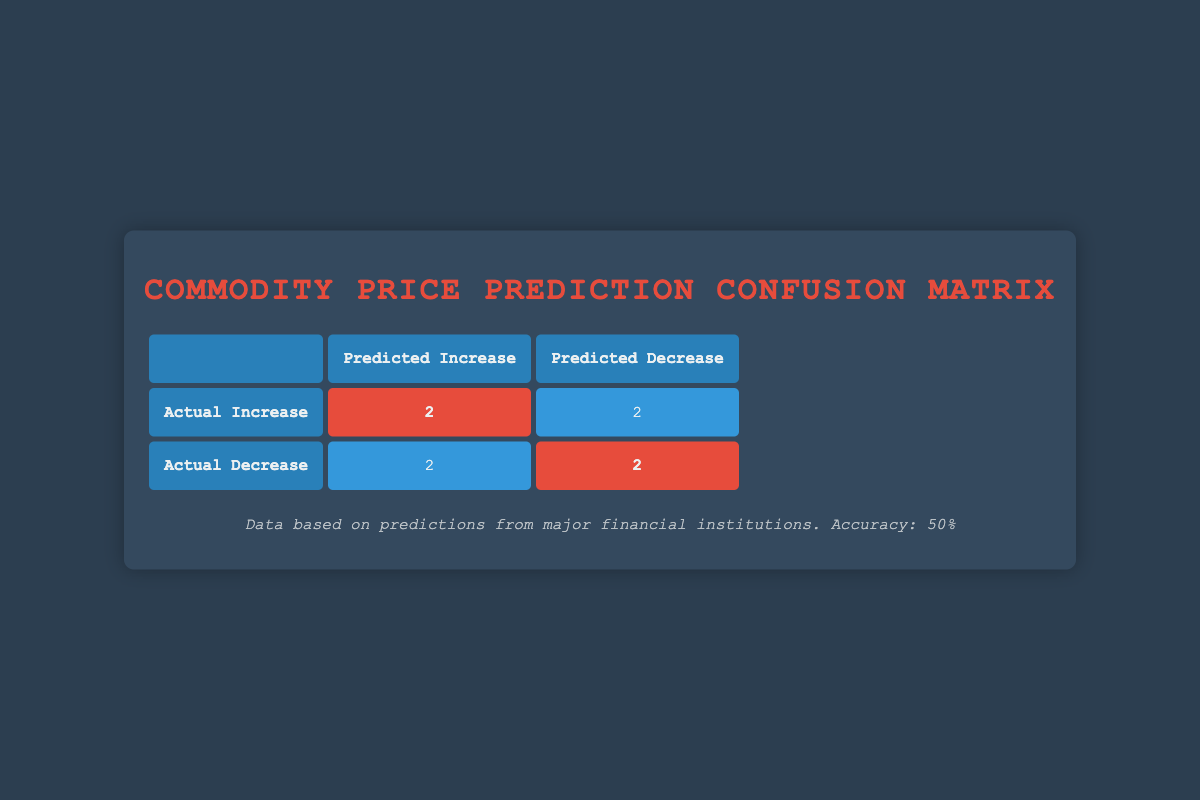What is the number of times the analysts predicted an increase when the actual price increased? Referring to the table, under the "Predicted Increase" column, we look for the cells where the "Actual Increase" is also marked. There are 2 instances: Goldman Sachs and Wells Fargo.
Answer: 2 What is the number of times the analysts predicted a decrease when the actual price decreased? Looking at the table, we count the "Predicted Decrease" entries for the "Actual Decrease" row. The analysts Barclays and JP Morgan fit this category, giving us a total of 2.
Answer: 2 How many analysts incorrectly predicted an increase? In the table, we find instances in the "Predicted Increase" row where the actual outcome was a decrease. There are 2 analysts: Morgan Stanley and Credit Suisse who made incorrect predictions.
Answer: 2 What is the total number of predictions made regarding price increases? To determine this, we sum the values in both the "Predicted Increase" cells, which are the total number of analysts who predicted an increase. We find 2 from the "Actual Increase" row and 2 from the "Actual Decrease" row, resulting in a total of 4 predictions.
Answer: 4 Is it true that more analysts incorrectly predicted a decrease than an increase? By comparing the counts of incorrect predictions, we see 2 analysts who incorrectly predicted an increase (Morgan Stanley and Credit Suisse) and 2 analysts who incorrectly predicted a decrease (CitiGroup and UBS). Therefore, the statement is false.
Answer: No What is the total number of correct predictions made by the analysts? To find the total correct predictions, we need to sum the highlights from both the "Actual Increase" and "Actual Decrease" rows. There are 2 correct predictions for increases and 2 for decreases, resulting in 4 correct predictions in total.
Answer: 4 What percentage of predictions were correct? Given that there are 8 total predictions (4 corrects from previous), we calculate the percentage: (4 correct predictions / 8 total predictions) * 100 = 50%.
Answer: 50% What is the number of total analysts included in the table? We can count the number of unique analysts listed in the table. There are 8 analysts: Goldman Sachs, JP Morgan, Morgan Stanley, CitiGroup, Wells Fargo, Barclays, Credit Suisse, and UBS, leading to a total of 8.
Answer: 8 